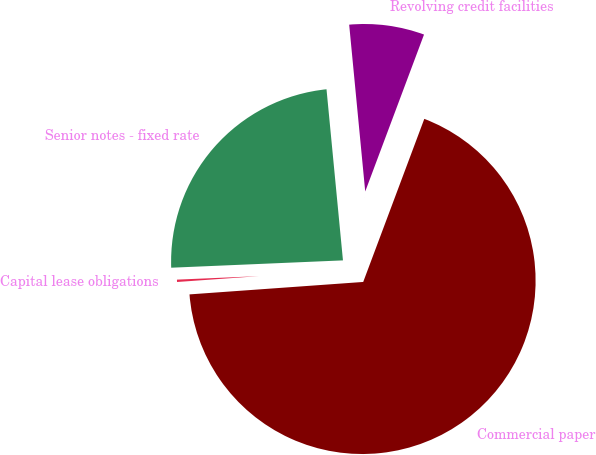Convert chart to OTSL. <chart><loc_0><loc_0><loc_500><loc_500><pie_chart><fcel>Commercial paper<fcel>Revolving credit facilities<fcel>Senior notes - fixed rate<fcel>Capital lease obligations<nl><fcel>68.15%<fcel>7.23%<fcel>24.15%<fcel>0.46%<nl></chart> 